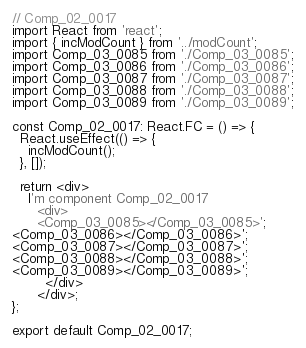Convert code to text. <code><loc_0><loc_0><loc_500><loc_500><_TypeScript_>// Comp_02_0017
import React from 'react';
import { incModCount } from '../modCount';
import Comp_03_0085 from './Comp_03_0085';
import Comp_03_0086 from './Comp_03_0086';
import Comp_03_0087 from './Comp_03_0087';
import Comp_03_0088 from './Comp_03_0088';
import Comp_03_0089 from './Comp_03_0089';

const Comp_02_0017: React.FC = () => {
  React.useEffect(() => {
    incModCount();
  }, []);

  return <div>
    I'm component Comp_02_0017
      <div>
      <Comp_03_0085></Comp_03_0085>';
<Comp_03_0086></Comp_03_0086>';
<Comp_03_0087></Comp_03_0087>';
<Comp_03_0088></Comp_03_0088>';
<Comp_03_0089></Comp_03_0089>';
        </div>
      </div>;
};

export default Comp_02_0017;
</code> 